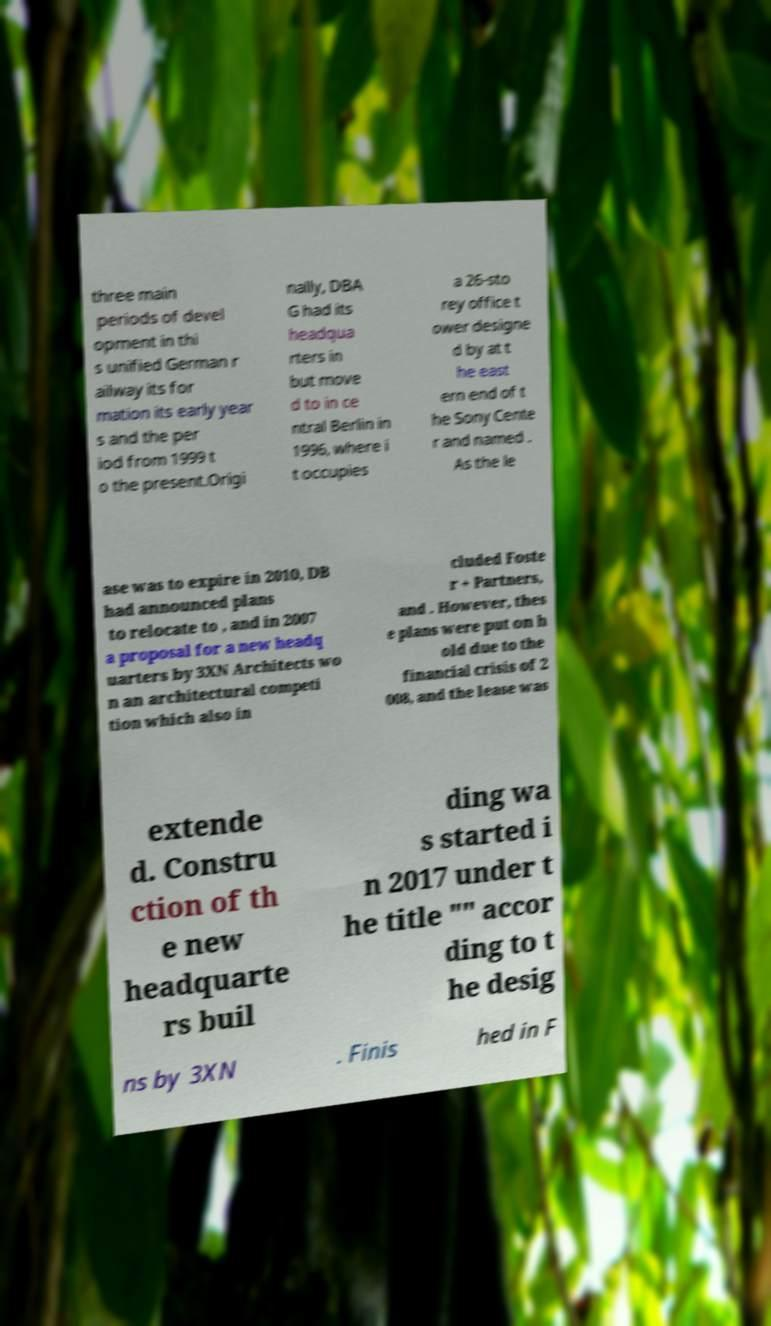What messages or text are displayed in this image? I need them in a readable, typed format. three main periods of devel opment in thi s unified German r ailway its for mation its early year s and the per iod from 1999 t o the present.Origi nally, DBA G had its headqua rters in but move d to in ce ntral Berlin in 1996, where i t occupies a 26-sto rey office t ower designe d by at t he east ern end of t he Sony Cente r and named . As the le ase was to expire in 2010, DB had announced plans to relocate to , and in 2007 a proposal for a new headq uarters by 3XN Architects wo n an architectural competi tion which also in cluded Foste r + Partners, and . However, thes e plans were put on h old due to the financial crisis of 2 008, and the lease was extende d. Constru ction of th e new headquarte rs buil ding wa s started i n 2017 under t he title "" accor ding to t he desig ns by 3XN . Finis hed in F 